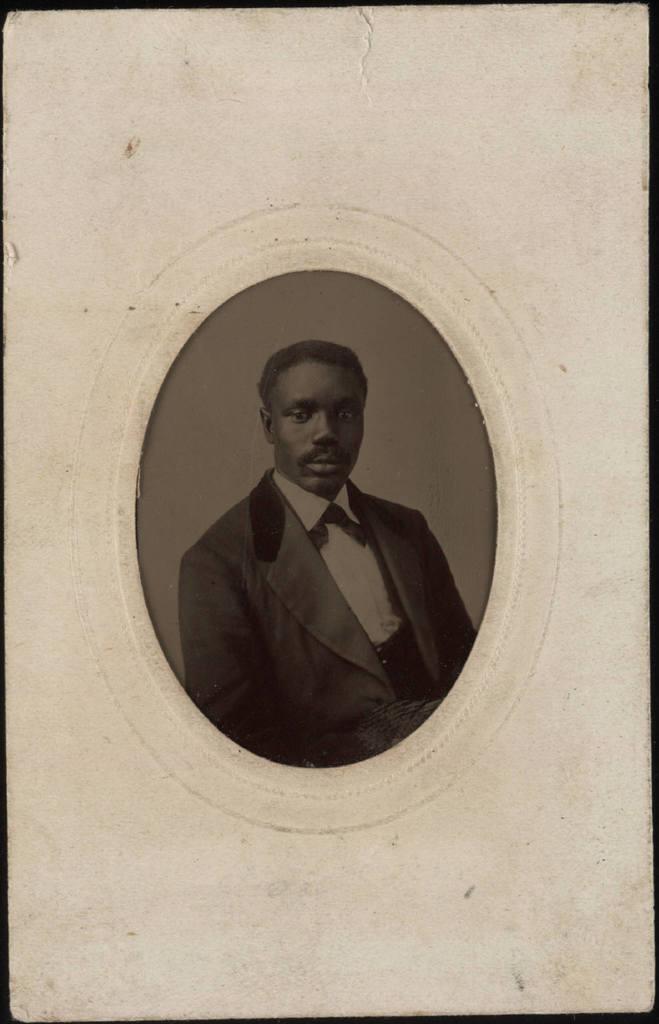Describe this image in one or two sentences. This picture is a black and white image. In this image we can see one man in suit photo and there is a white background. 